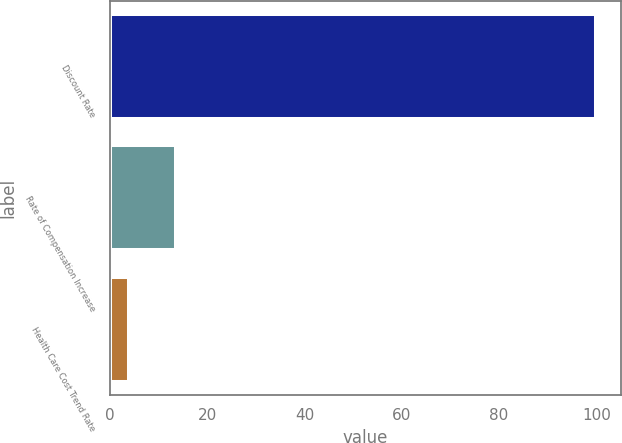Convert chart to OTSL. <chart><loc_0><loc_0><loc_500><loc_500><bar_chart><fcel>Discount Rate<fcel>Rate of Compensation Increase<fcel>Health Care Cost Trend Rate<nl><fcel>100<fcel>13.6<fcel>4<nl></chart> 